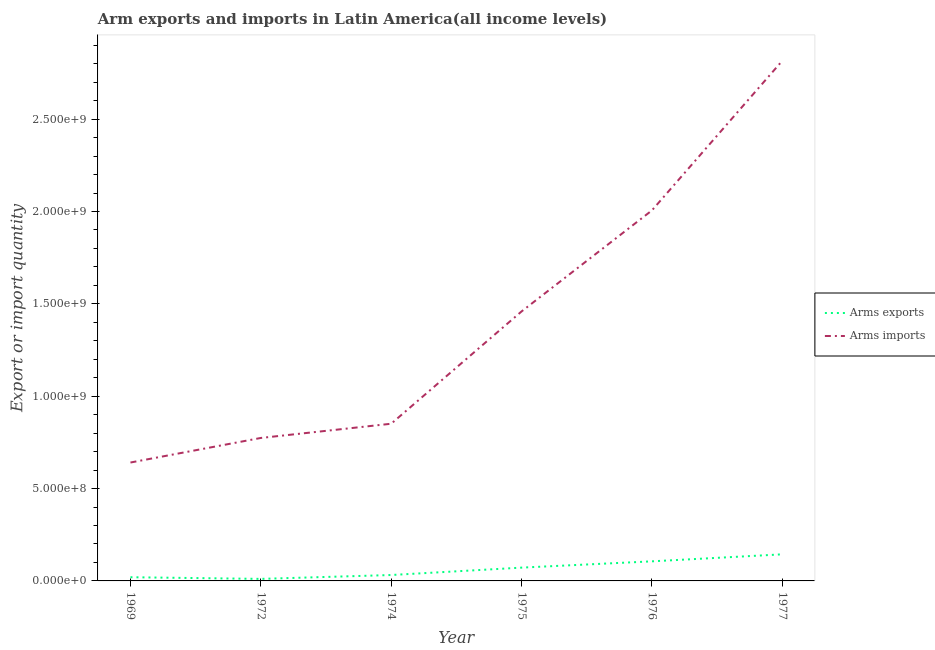Is the number of lines equal to the number of legend labels?
Your answer should be very brief. Yes. What is the arms imports in 1969?
Your response must be concise. 6.41e+08. Across all years, what is the maximum arms exports?
Your response must be concise. 1.44e+08. Across all years, what is the minimum arms exports?
Your response must be concise. 1.10e+07. In which year was the arms exports minimum?
Give a very brief answer. 1972. What is the total arms imports in the graph?
Make the answer very short. 8.55e+09. What is the difference between the arms exports in 1969 and that in 1974?
Ensure brevity in your answer.  -1.20e+07. What is the difference between the arms imports in 1972 and the arms exports in 1969?
Your answer should be compact. 7.54e+08. What is the average arms imports per year?
Offer a terse response. 1.42e+09. In the year 1972, what is the difference between the arms exports and arms imports?
Your answer should be very brief. -7.63e+08. What is the ratio of the arms imports in 1969 to that in 1976?
Make the answer very short. 0.32. Is the arms exports in 1976 less than that in 1977?
Offer a very short reply. Yes. What is the difference between the highest and the second highest arms exports?
Your answer should be compact. 3.80e+07. What is the difference between the highest and the lowest arms imports?
Ensure brevity in your answer.  2.18e+09. Is the sum of the arms imports in 1975 and 1977 greater than the maximum arms exports across all years?
Provide a short and direct response. Yes. Does the arms imports monotonically increase over the years?
Your response must be concise. Yes. How many lines are there?
Your response must be concise. 2. How many years are there in the graph?
Make the answer very short. 6. Are the values on the major ticks of Y-axis written in scientific E-notation?
Keep it short and to the point. Yes. Does the graph contain grids?
Give a very brief answer. No. How many legend labels are there?
Provide a short and direct response. 2. What is the title of the graph?
Your answer should be compact. Arm exports and imports in Latin America(all income levels). Does "Highest 10% of population" appear as one of the legend labels in the graph?
Give a very brief answer. No. What is the label or title of the X-axis?
Provide a succinct answer. Year. What is the label or title of the Y-axis?
Your answer should be compact. Export or import quantity. What is the Export or import quantity of Arms exports in 1969?
Offer a terse response. 2.00e+07. What is the Export or import quantity of Arms imports in 1969?
Your answer should be compact. 6.41e+08. What is the Export or import quantity of Arms exports in 1972?
Ensure brevity in your answer.  1.10e+07. What is the Export or import quantity in Arms imports in 1972?
Your answer should be very brief. 7.74e+08. What is the Export or import quantity of Arms exports in 1974?
Your response must be concise. 3.20e+07. What is the Export or import quantity of Arms imports in 1974?
Offer a terse response. 8.51e+08. What is the Export or import quantity of Arms exports in 1975?
Provide a succinct answer. 7.20e+07. What is the Export or import quantity in Arms imports in 1975?
Ensure brevity in your answer.  1.46e+09. What is the Export or import quantity of Arms exports in 1976?
Offer a very short reply. 1.06e+08. What is the Export or import quantity in Arms imports in 1976?
Offer a terse response. 2.01e+09. What is the Export or import quantity of Arms exports in 1977?
Provide a succinct answer. 1.44e+08. What is the Export or import quantity in Arms imports in 1977?
Your answer should be compact. 2.82e+09. Across all years, what is the maximum Export or import quantity in Arms exports?
Provide a short and direct response. 1.44e+08. Across all years, what is the maximum Export or import quantity in Arms imports?
Keep it short and to the point. 2.82e+09. Across all years, what is the minimum Export or import quantity in Arms exports?
Provide a short and direct response. 1.10e+07. Across all years, what is the minimum Export or import quantity in Arms imports?
Give a very brief answer. 6.41e+08. What is the total Export or import quantity of Arms exports in the graph?
Ensure brevity in your answer.  3.85e+08. What is the total Export or import quantity of Arms imports in the graph?
Your answer should be compact. 8.55e+09. What is the difference between the Export or import quantity of Arms exports in 1969 and that in 1972?
Keep it short and to the point. 9.00e+06. What is the difference between the Export or import quantity of Arms imports in 1969 and that in 1972?
Ensure brevity in your answer.  -1.33e+08. What is the difference between the Export or import quantity in Arms exports in 1969 and that in 1974?
Give a very brief answer. -1.20e+07. What is the difference between the Export or import quantity of Arms imports in 1969 and that in 1974?
Provide a short and direct response. -2.10e+08. What is the difference between the Export or import quantity in Arms exports in 1969 and that in 1975?
Give a very brief answer. -5.20e+07. What is the difference between the Export or import quantity in Arms imports in 1969 and that in 1975?
Offer a terse response. -8.18e+08. What is the difference between the Export or import quantity in Arms exports in 1969 and that in 1976?
Make the answer very short. -8.60e+07. What is the difference between the Export or import quantity of Arms imports in 1969 and that in 1976?
Offer a terse response. -1.36e+09. What is the difference between the Export or import quantity in Arms exports in 1969 and that in 1977?
Offer a very short reply. -1.24e+08. What is the difference between the Export or import quantity of Arms imports in 1969 and that in 1977?
Provide a short and direct response. -2.18e+09. What is the difference between the Export or import quantity in Arms exports in 1972 and that in 1974?
Keep it short and to the point. -2.10e+07. What is the difference between the Export or import quantity of Arms imports in 1972 and that in 1974?
Your answer should be compact. -7.70e+07. What is the difference between the Export or import quantity in Arms exports in 1972 and that in 1975?
Ensure brevity in your answer.  -6.10e+07. What is the difference between the Export or import quantity in Arms imports in 1972 and that in 1975?
Provide a short and direct response. -6.85e+08. What is the difference between the Export or import quantity in Arms exports in 1972 and that in 1976?
Offer a terse response. -9.50e+07. What is the difference between the Export or import quantity of Arms imports in 1972 and that in 1976?
Your answer should be very brief. -1.23e+09. What is the difference between the Export or import quantity of Arms exports in 1972 and that in 1977?
Keep it short and to the point. -1.33e+08. What is the difference between the Export or import quantity of Arms imports in 1972 and that in 1977?
Offer a very short reply. -2.04e+09. What is the difference between the Export or import quantity of Arms exports in 1974 and that in 1975?
Provide a succinct answer. -4.00e+07. What is the difference between the Export or import quantity in Arms imports in 1974 and that in 1975?
Keep it short and to the point. -6.08e+08. What is the difference between the Export or import quantity of Arms exports in 1974 and that in 1976?
Ensure brevity in your answer.  -7.40e+07. What is the difference between the Export or import quantity in Arms imports in 1974 and that in 1976?
Your answer should be very brief. -1.16e+09. What is the difference between the Export or import quantity in Arms exports in 1974 and that in 1977?
Your answer should be very brief. -1.12e+08. What is the difference between the Export or import quantity of Arms imports in 1974 and that in 1977?
Provide a short and direct response. -1.96e+09. What is the difference between the Export or import quantity in Arms exports in 1975 and that in 1976?
Your response must be concise. -3.40e+07. What is the difference between the Export or import quantity in Arms imports in 1975 and that in 1976?
Provide a succinct answer. -5.47e+08. What is the difference between the Export or import quantity in Arms exports in 1975 and that in 1977?
Your response must be concise. -7.20e+07. What is the difference between the Export or import quantity of Arms imports in 1975 and that in 1977?
Offer a very short reply. -1.36e+09. What is the difference between the Export or import quantity in Arms exports in 1976 and that in 1977?
Keep it short and to the point. -3.80e+07. What is the difference between the Export or import quantity of Arms imports in 1976 and that in 1977?
Offer a very short reply. -8.10e+08. What is the difference between the Export or import quantity of Arms exports in 1969 and the Export or import quantity of Arms imports in 1972?
Your answer should be compact. -7.54e+08. What is the difference between the Export or import quantity in Arms exports in 1969 and the Export or import quantity in Arms imports in 1974?
Offer a very short reply. -8.31e+08. What is the difference between the Export or import quantity in Arms exports in 1969 and the Export or import quantity in Arms imports in 1975?
Provide a short and direct response. -1.44e+09. What is the difference between the Export or import quantity of Arms exports in 1969 and the Export or import quantity of Arms imports in 1976?
Keep it short and to the point. -1.99e+09. What is the difference between the Export or import quantity in Arms exports in 1969 and the Export or import quantity in Arms imports in 1977?
Give a very brief answer. -2.80e+09. What is the difference between the Export or import quantity in Arms exports in 1972 and the Export or import quantity in Arms imports in 1974?
Keep it short and to the point. -8.40e+08. What is the difference between the Export or import quantity of Arms exports in 1972 and the Export or import quantity of Arms imports in 1975?
Keep it short and to the point. -1.45e+09. What is the difference between the Export or import quantity in Arms exports in 1972 and the Export or import quantity in Arms imports in 1976?
Your answer should be very brief. -2.00e+09. What is the difference between the Export or import quantity in Arms exports in 1972 and the Export or import quantity in Arms imports in 1977?
Offer a very short reply. -2.80e+09. What is the difference between the Export or import quantity of Arms exports in 1974 and the Export or import quantity of Arms imports in 1975?
Provide a short and direct response. -1.43e+09. What is the difference between the Export or import quantity in Arms exports in 1974 and the Export or import quantity in Arms imports in 1976?
Your answer should be compact. -1.97e+09. What is the difference between the Export or import quantity of Arms exports in 1974 and the Export or import quantity of Arms imports in 1977?
Provide a succinct answer. -2.78e+09. What is the difference between the Export or import quantity in Arms exports in 1975 and the Export or import quantity in Arms imports in 1976?
Your answer should be very brief. -1.93e+09. What is the difference between the Export or import quantity of Arms exports in 1975 and the Export or import quantity of Arms imports in 1977?
Give a very brief answer. -2.74e+09. What is the difference between the Export or import quantity in Arms exports in 1976 and the Export or import quantity in Arms imports in 1977?
Make the answer very short. -2.71e+09. What is the average Export or import quantity in Arms exports per year?
Give a very brief answer. 6.42e+07. What is the average Export or import quantity in Arms imports per year?
Make the answer very short. 1.42e+09. In the year 1969, what is the difference between the Export or import quantity of Arms exports and Export or import quantity of Arms imports?
Offer a very short reply. -6.21e+08. In the year 1972, what is the difference between the Export or import quantity of Arms exports and Export or import quantity of Arms imports?
Ensure brevity in your answer.  -7.63e+08. In the year 1974, what is the difference between the Export or import quantity in Arms exports and Export or import quantity in Arms imports?
Make the answer very short. -8.19e+08. In the year 1975, what is the difference between the Export or import quantity of Arms exports and Export or import quantity of Arms imports?
Give a very brief answer. -1.39e+09. In the year 1976, what is the difference between the Export or import quantity of Arms exports and Export or import quantity of Arms imports?
Your response must be concise. -1.90e+09. In the year 1977, what is the difference between the Export or import quantity in Arms exports and Export or import quantity in Arms imports?
Your answer should be compact. -2.67e+09. What is the ratio of the Export or import quantity of Arms exports in 1969 to that in 1972?
Give a very brief answer. 1.82. What is the ratio of the Export or import quantity in Arms imports in 1969 to that in 1972?
Ensure brevity in your answer.  0.83. What is the ratio of the Export or import quantity of Arms imports in 1969 to that in 1974?
Keep it short and to the point. 0.75. What is the ratio of the Export or import quantity in Arms exports in 1969 to that in 1975?
Your answer should be very brief. 0.28. What is the ratio of the Export or import quantity in Arms imports in 1969 to that in 1975?
Provide a succinct answer. 0.44. What is the ratio of the Export or import quantity in Arms exports in 1969 to that in 1976?
Offer a terse response. 0.19. What is the ratio of the Export or import quantity of Arms imports in 1969 to that in 1976?
Your response must be concise. 0.32. What is the ratio of the Export or import quantity of Arms exports in 1969 to that in 1977?
Keep it short and to the point. 0.14. What is the ratio of the Export or import quantity of Arms imports in 1969 to that in 1977?
Offer a very short reply. 0.23. What is the ratio of the Export or import quantity of Arms exports in 1972 to that in 1974?
Your answer should be very brief. 0.34. What is the ratio of the Export or import quantity in Arms imports in 1972 to that in 1974?
Ensure brevity in your answer.  0.91. What is the ratio of the Export or import quantity of Arms exports in 1972 to that in 1975?
Provide a short and direct response. 0.15. What is the ratio of the Export or import quantity of Arms imports in 1972 to that in 1975?
Provide a succinct answer. 0.53. What is the ratio of the Export or import quantity in Arms exports in 1972 to that in 1976?
Offer a terse response. 0.1. What is the ratio of the Export or import quantity of Arms imports in 1972 to that in 1976?
Provide a succinct answer. 0.39. What is the ratio of the Export or import quantity of Arms exports in 1972 to that in 1977?
Keep it short and to the point. 0.08. What is the ratio of the Export or import quantity of Arms imports in 1972 to that in 1977?
Make the answer very short. 0.27. What is the ratio of the Export or import quantity of Arms exports in 1974 to that in 1975?
Provide a succinct answer. 0.44. What is the ratio of the Export or import quantity of Arms imports in 1974 to that in 1975?
Your answer should be very brief. 0.58. What is the ratio of the Export or import quantity of Arms exports in 1974 to that in 1976?
Provide a succinct answer. 0.3. What is the ratio of the Export or import quantity in Arms imports in 1974 to that in 1976?
Ensure brevity in your answer.  0.42. What is the ratio of the Export or import quantity in Arms exports in 1974 to that in 1977?
Offer a very short reply. 0.22. What is the ratio of the Export or import quantity in Arms imports in 1974 to that in 1977?
Your answer should be compact. 0.3. What is the ratio of the Export or import quantity in Arms exports in 1975 to that in 1976?
Your answer should be very brief. 0.68. What is the ratio of the Export or import quantity of Arms imports in 1975 to that in 1976?
Your response must be concise. 0.73. What is the ratio of the Export or import quantity of Arms exports in 1975 to that in 1977?
Ensure brevity in your answer.  0.5. What is the ratio of the Export or import quantity of Arms imports in 1975 to that in 1977?
Offer a very short reply. 0.52. What is the ratio of the Export or import quantity of Arms exports in 1976 to that in 1977?
Provide a succinct answer. 0.74. What is the ratio of the Export or import quantity of Arms imports in 1976 to that in 1977?
Offer a very short reply. 0.71. What is the difference between the highest and the second highest Export or import quantity of Arms exports?
Provide a short and direct response. 3.80e+07. What is the difference between the highest and the second highest Export or import quantity in Arms imports?
Give a very brief answer. 8.10e+08. What is the difference between the highest and the lowest Export or import quantity of Arms exports?
Your response must be concise. 1.33e+08. What is the difference between the highest and the lowest Export or import quantity in Arms imports?
Provide a succinct answer. 2.18e+09. 